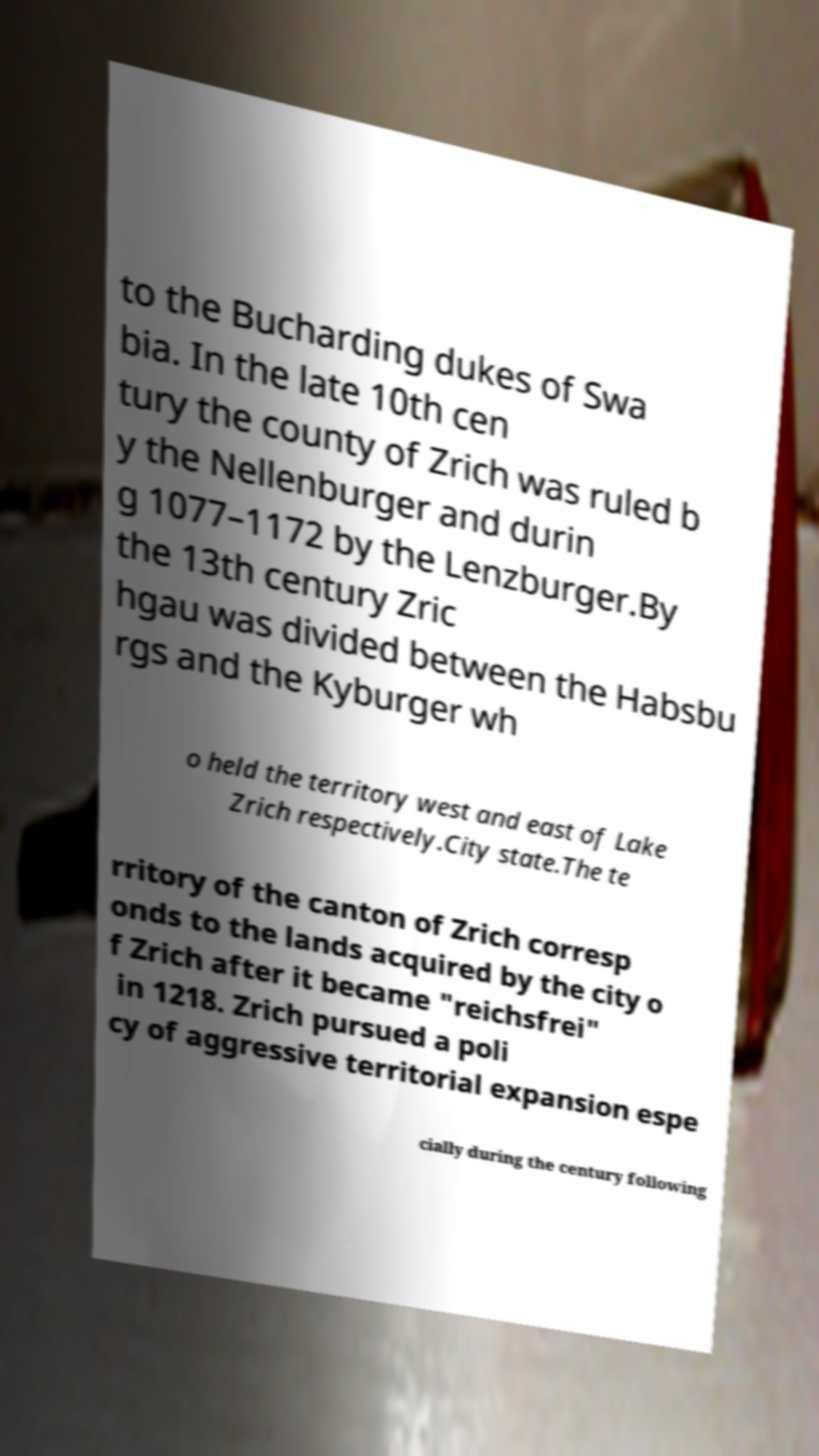Could you extract and type out the text from this image? to the Bucharding dukes of Swa bia. In the late 10th cen tury the county of Zrich was ruled b y the Nellenburger and durin g 1077–1172 by the Lenzburger.By the 13th century Zric hgau was divided between the Habsbu rgs and the Kyburger wh o held the territory west and east of Lake Zrich respectively.City state.The te rritory of the canton of Zrich corresp onds to the lands acquired by the city o f Zrich after it became "reichsfrei" in 1218. Zrich pursued a poli cy of aggressive territorial expansion espe cially during the century following 